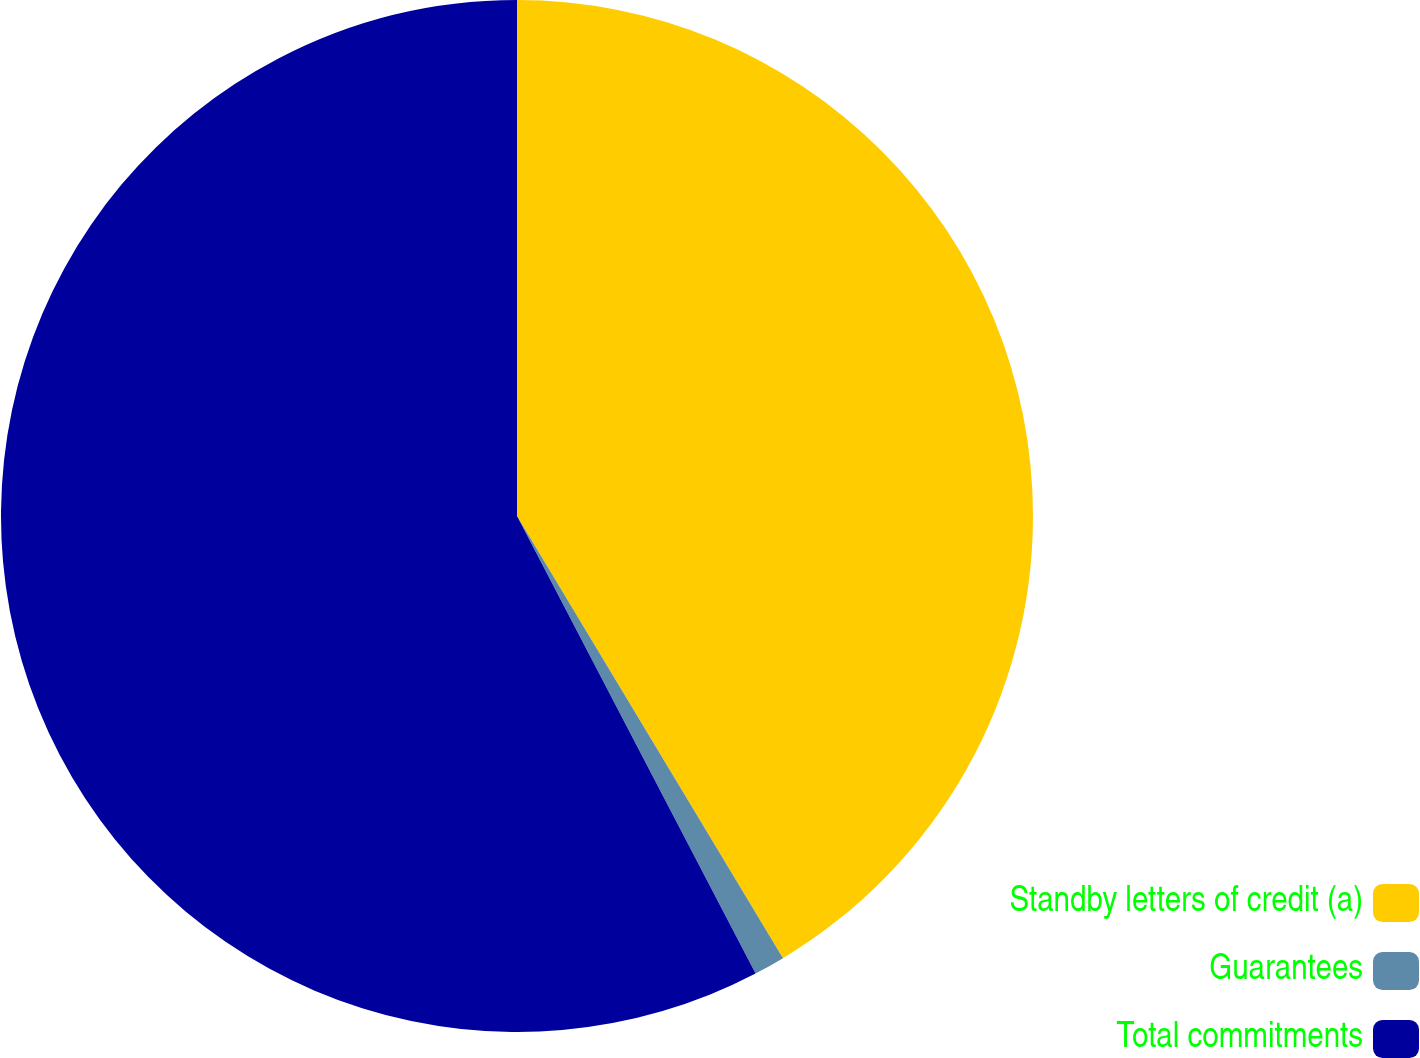Convert chart. <chart><loc_0><loc_0><loc_500><loc_500><pie_chart><fcel>Standby letters of credit (a)<fcel>Guarantees<fcel>Total commitments<nl><fcel>41.38%<fcel>0.97%<fcel>57.65%<nl></chart> 